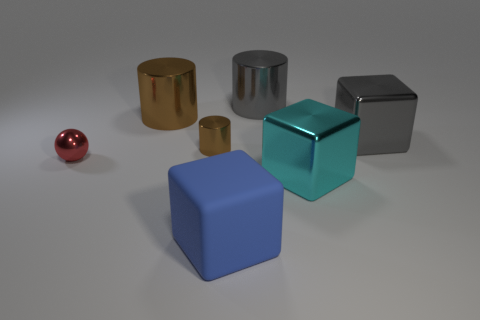Do the gray metal object that is on the right side of the large cyan thing and the blue rubber thing on the left side of the cyan cube have the same size?
Your response must be concise. Yes. Is there a gray cylinder that has the same size as the cyan cube?
Offer a very short reply. Yes. There is a large gray metal object that is in front of the big brown cylinder; does it have the same shape as the tiny brown object?
Your answer should be very brief. No. There is a large cylinder that is left of the small brown shiny object; what is it made of?
Your response must be concise. Metal. What shape is the gray metal thing on the left side of the gray thing on the right side of the large gray cylinder?
Offer a terse response. Cylinder. Is the shape of the matte thing the same as the big object left of the tiny metallic cylinder?
Provide a succinct answer. No. How many brown metallic things are left of the small object that is right of the large brown thing?
Your answer should be very brief. 1. There is a gray object that is the same shape as the cyan thing; what is it made of?
Offer a very short reply. Metal. What number of red objects are tiny metallic spheres or big things?
Offer a very short reply. 1. Is there any other thing that has the same color as the small cylinder?
Your answer should be very brief. Yes. 